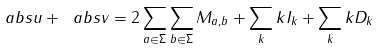<formula> <loc_0><loc_0><loc_500><loc_500>\ a b s { u } + \ a b s { v } = 2 \sum _ { a \in \Sigma } \sum _ { b \in \Sigma } M _ { a , b } + \sum _ { k } k I _ { k } + \sum _ { k } k D _ { k }</formula> 